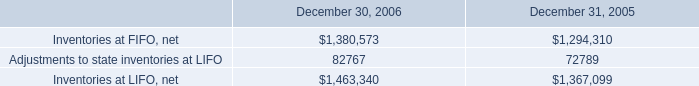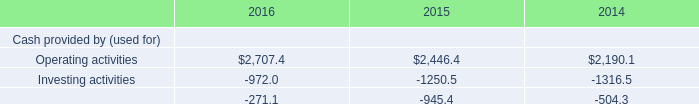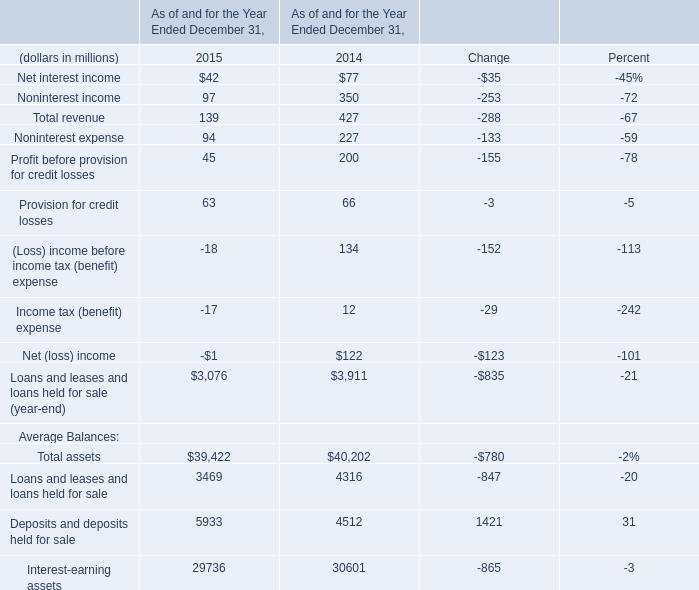What is the sum of the Total assets in the years where Income tax (benefit) is positive? (in million) 
Answer: 40,202. 